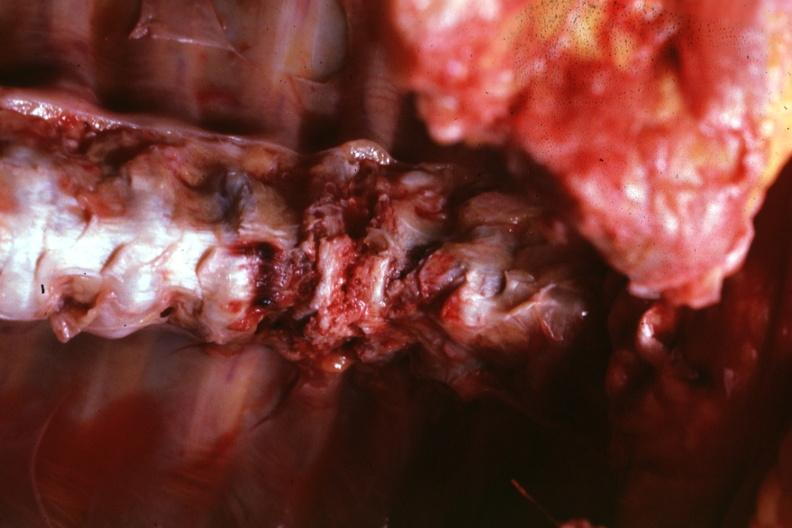what does this image show?
Answer the question using a single word or phrase. In situ close-up well shown 